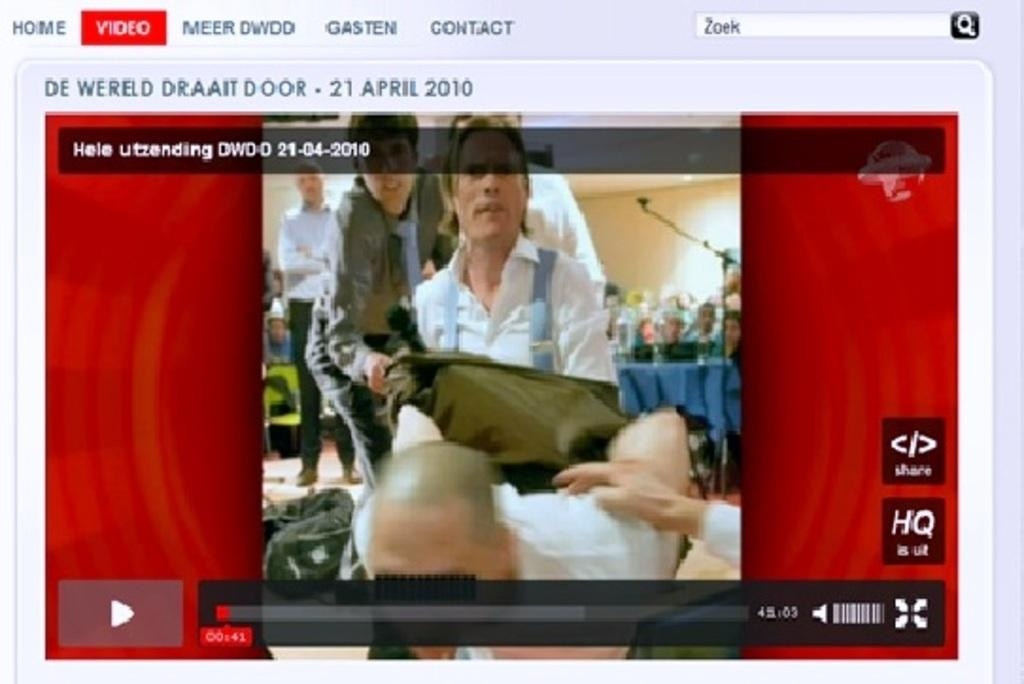<image>
Render a clear and concise summary of the photo. a video on a screen playing at the time of 41 seconds 